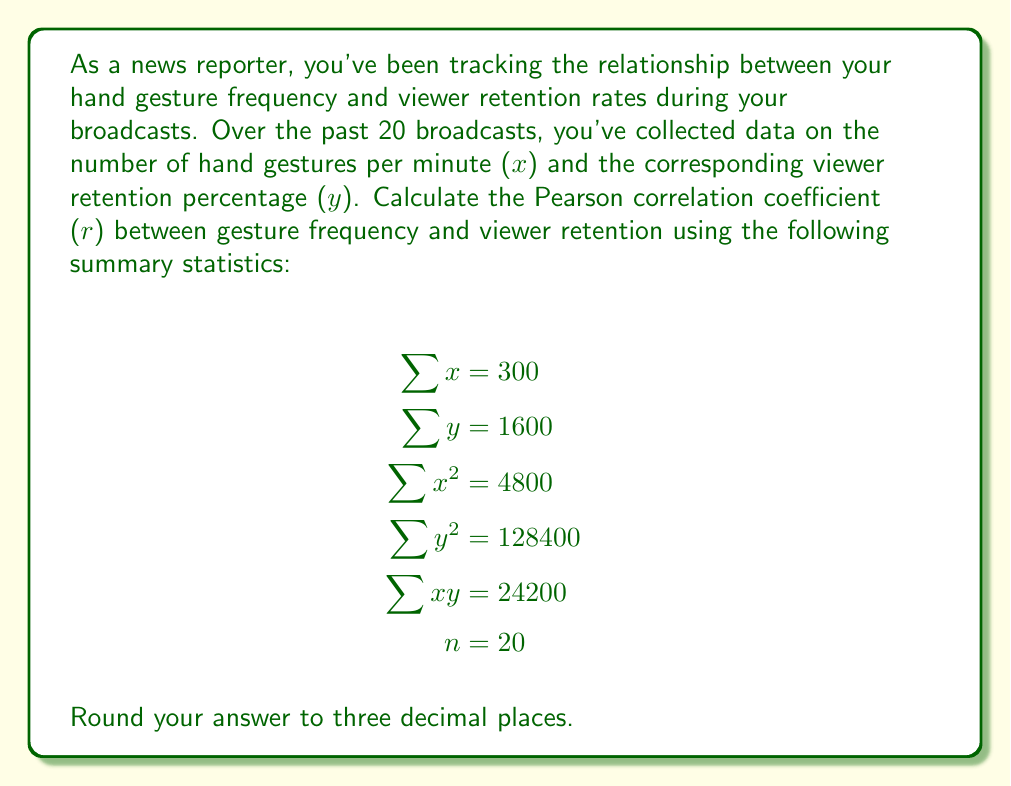Teach me how to tackle this problem. To calculate the Pearson correlation coefficient (r), we'll use the formula:

$$r = \frac{n(\sum xy) - (\sum x)(\sum y)}{\sqrt{[n(\sum x^2) - (\sum x)^2][n(\sum y^2) - (\sum y)^2]}}$$

Let's substitute the given values:

1. Calculate $n(\sum xy)$:
   $20 \times 24200 = 484000$

2. Calculate $(\sum x)(\sum y)$:
   $300 \times 1600 = 480000$

3. Calculate $n(\sum x^2)$:
   $20 \times 4800 = 96000$

4. Calculate $(\sum x)^2$:
   $300^2 = 90000$

5. Calculate $n(\sum y^2)$:
   $20 \times 128400 = 2568000$

6. Calculate $(\sum y)^2$:
   $1600^2 = 2560000$

Now, let's substitute these values into the formula:

$$r = \frac{484000 - 480000}{\sqrt{(96000 - 90000)(2568000 - 2560000)}}$$

$$r = \frac{4000}{\sqrt{6000 \times 8000}}$$

$$r = \frac{4000}{\sqrt{48000000}}$$

$$r = \frac{4000}{6928.203}$$

$$r \approx 0.577$$

Rounding to three decimal places, we get 0.577.
Answer: 0.577 